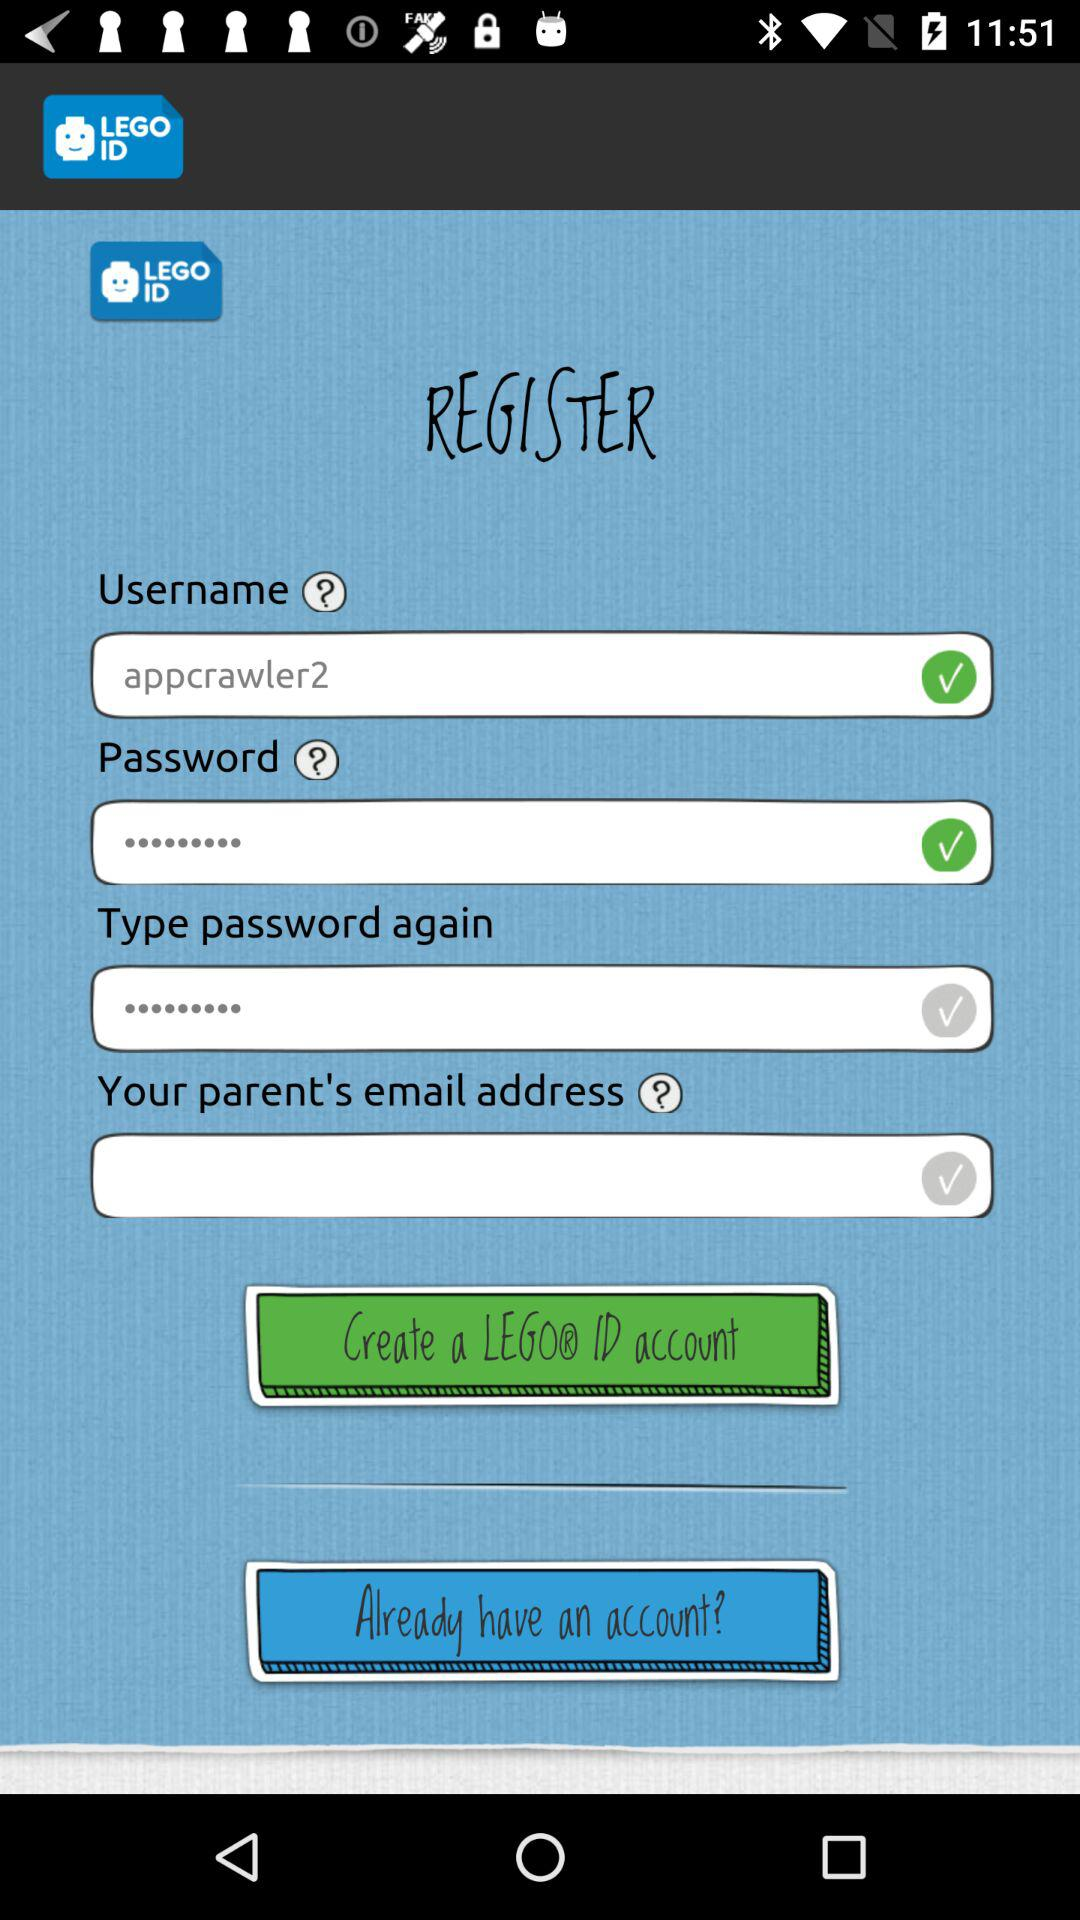What is the username? The username is "appcrawler2". 